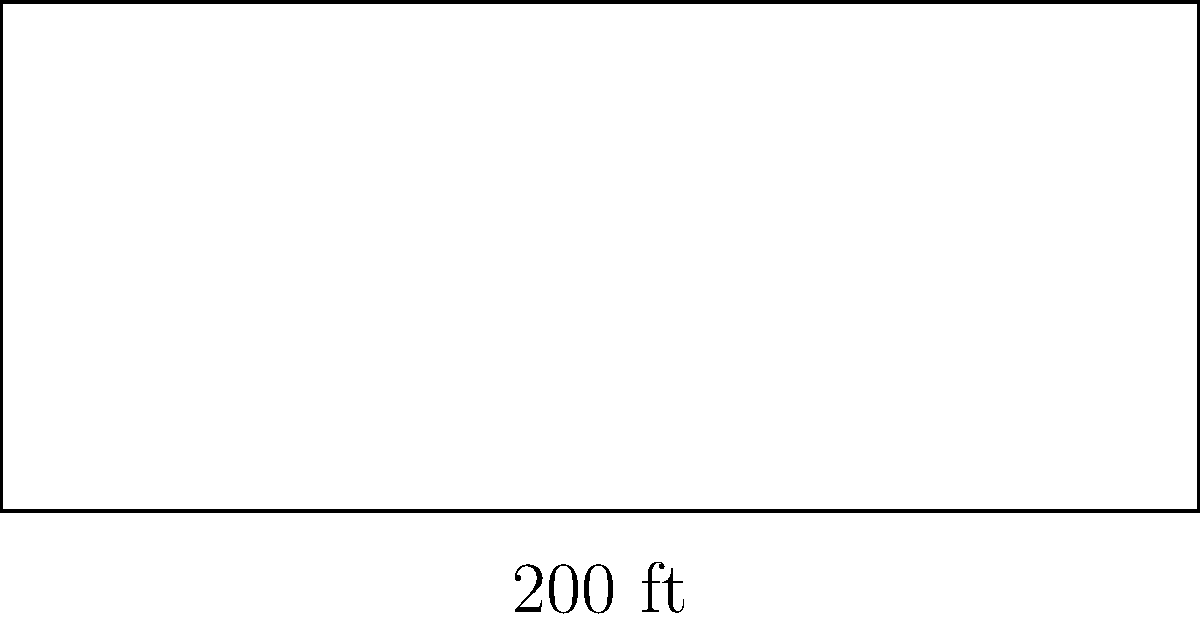As a retired hockey coach, you're revisiting the dimensions of an NHL rink. Given that a standard NHL rink is 200 feet long and 85 feet wide, what are the coordinates of the center point of the rink if we place the origin $(0,0)$ at the bottom-left corner? Let's approach this step-by-step:

1) The NHL rink is rectangular, with dimensions 200 feet long and 85 feet wide.

2) We're placing the origin $(0,0)$ at the bottom-left corner of the rink.

3) To find the center, we need to find the midpoint of both the length and width:

   For the length (x-coordinate):
   $x = \frac{200}{2} = 100$ feet

   For the width (y-coordinate):
   $y = \frac{85}{2} = 42.5$ feet

4) Therefore, the center point is located at $(100, 42.5)$.

This point represents the center ice, where face-offs often occur at the start of periods or after goals in traditional NHL games.
Answer: $(100, 42.5)$ 